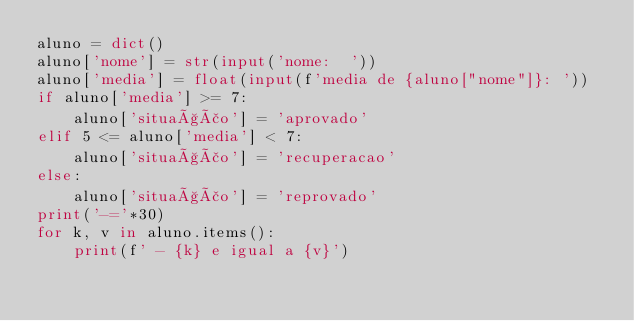<code> <loc_0><loc_0><loc_500><loc_500><_Python_>aluno = dict()
aluno['nome'] = str(input('nome:  '))
aluno['media'] = float(input(f'media de {aluno["nome"]}: '))
if aluno['media'] >= 7:
    aluno['situação'] = 'aprovado'
elif 5 <= aluno['media'] < 7:
    aluno['situação'] = 'recuperacao'
else:
    aluno['situação'] = 'reprovado'
print('-='*30)
for k, v in aluno.items():
    print(f' - {k} e igual a {v}')
</code> 